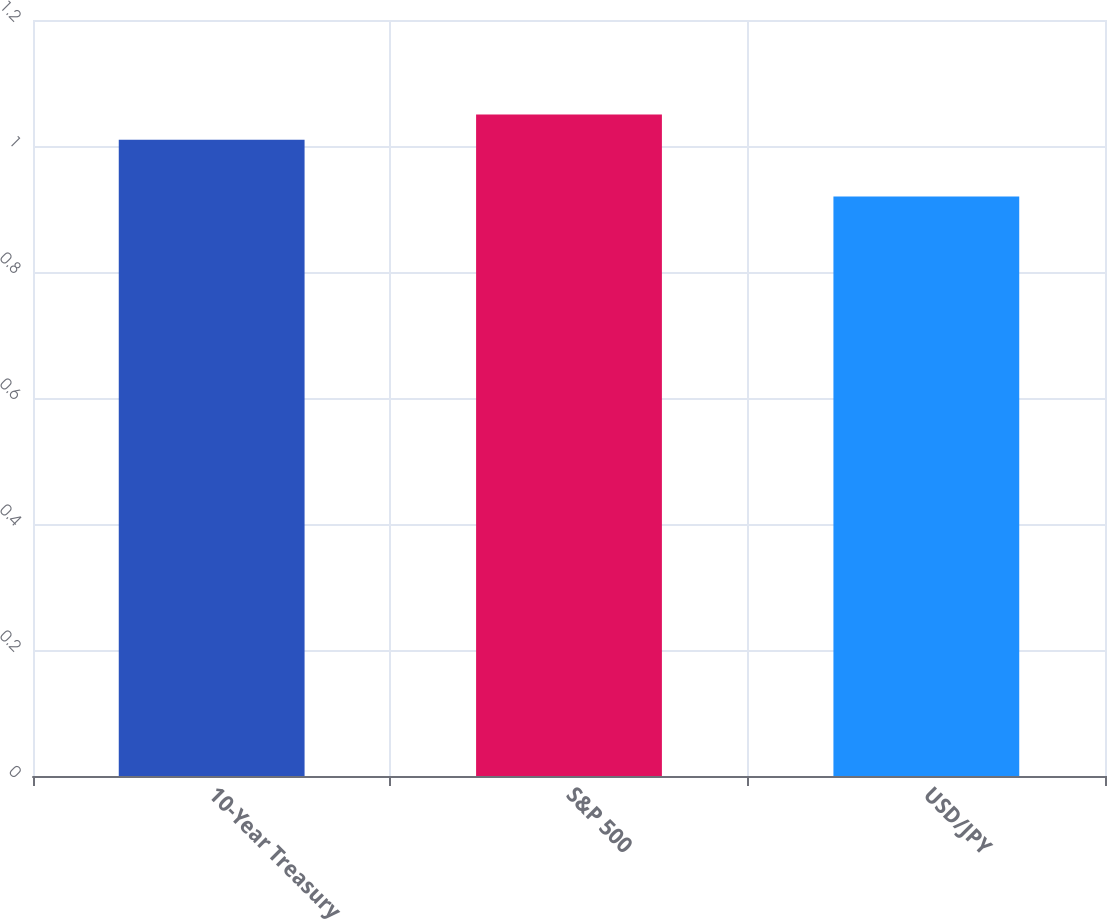Convert chart. <chart><loc_0><loc_0><loc_500><loc_500><bar_chart><fcel>10-Year Treasury<fcel>S&P 500<fcel>USD/JPY<nl><fcel>1.01<fcel>1.05<fcel>0.92<nl></chart> 